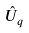<formula> <loc_0><loc_0><loc_500><loc_500>\hat { U } _ { q }</formula> 